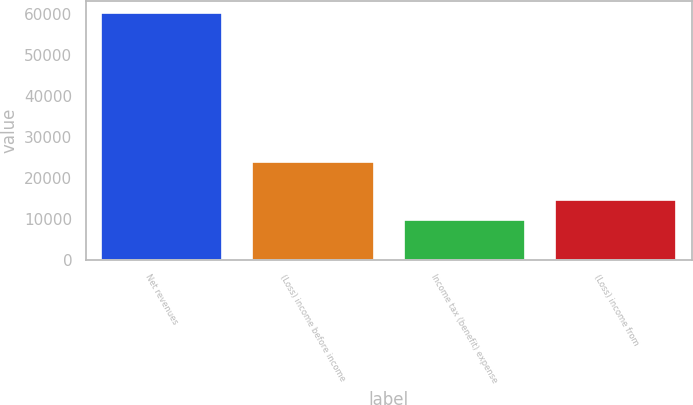Convert chart. <chart><loc_0><loc_0><loc_500><loc_500><bar_chart><fcel>Net revenues<fcel>(Loss) income before income<fcel>Income tax (benefit) expense<fcel>(Loss) income from<nl><fcel>60174<fcel>23931<fcel>9548<fcel>14610.6<nl></chart> 